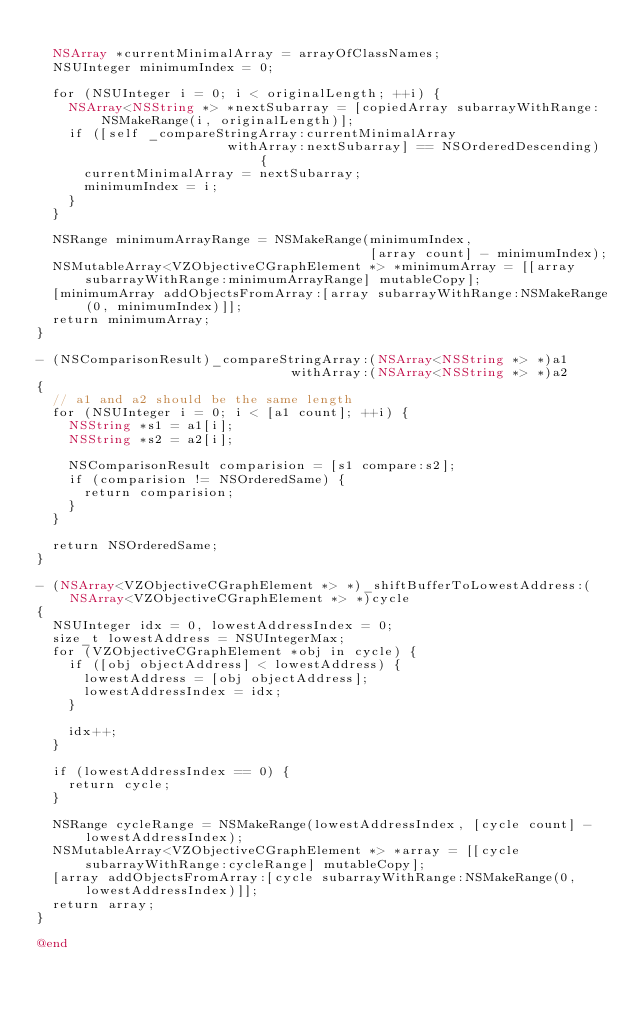Convert code to text. <code><loc_0><loc_0><loc_500><loc_500><_ObjectiveC_>
  NSArray *currentMinimalArray = arrayOfClassNames;
  NSUInteger minimumIndex = 0;

  for (NSUInteger i = 0; i < originalLength; ++i) {
    NSArray<NSString *> *nextSubarray = [copiedArray subarrayWithRange:NSMakeRange(i, originalLength)];
    if ([self _compareStringArray:currentMinimalArray
                        withArray:nextSubarray] == NSOrderedDescending) {
      currentMinimalArray = nextSubarray;
      minimumIndex = i;
    }
  }

  NSRange minimumArrayRange = NSMakeRange(minimumIndex,
                                          [array count] - minimumIndex);
  NSMutableArray<VZObjectiveCGraphElement *> *minimumArray = [[array subarrayWithRange:minimumArrayRange] mutableCopy];
  [minimumArray addObjectsFromArray:[array subarrayWithRange:NSMakeRange(0, minimumIndex)]];
  return minimumArray;
}

- (NSComparisonResult)_compareStringArray:(NSArray<NSString *> *)a1
                                withArray:(NSArray<NSString *> *)a2
{
  // a1 and a2 should be the same length
  for (NSUInteger i = 0; i < [a1 count]; ++i) {
    NSString *s1 = a1[i];
    NSString *s2 = a2[i];

    NSComparisonResult comparision = [s1 compare:s2];
    if (comparision != NSOrderedSame) {
      return comparision;
    }
  }

  return NSOrderedSame;
}

- (NSArray<VZObjectiveCGraphElement *> *)_shiftBufferToLowestAddress:(NSArray<VZObjectiveCGraphElement *> *)cycle
{
  NSUInteger idx = 0, lowestAddressIndex = 0;
  size_t lowestAddress = NSUIntegerMax;
  for (VZObjectiveCGraphElement *obj in cycle) {
    if ([obj objectAddress] < lowestAddress) {
      lowestAddress = [obj objectAddress];
      lowestAddressIndex = idx;
    }

    idx++;
  }

  if (lowestAddressIndex == 0) {
    return cycle;
  }

  NSRange cycleRange = NSMakeRange(lowestAddressIndex, [cycle count] - lowestAddressIndex);
  NSMutableArray<VZObjectiveCGraphElement *> *array = [[cycle subarrayWithRange:cycleRange] mutableCopy];
  [array addObjectsFromArray:[cycle subarrayWithRange:NSMakeRange(0, lowestAddressIndex)]];
  return array;
}

@end
</code> 